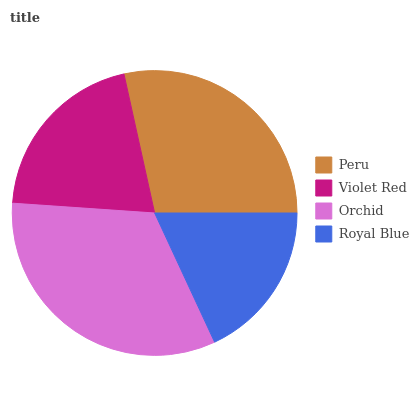Is Royal Blue the minimum?
Answer yes or no. Yes. Is Orchid the maximum?
Answer yes or no. Yes. Is Violet Red the minimum?
Answer yes or no. No. Is Violet Red the maximum?
Answer yes or no. No. Is Peru greater than Violet Red?
Answer yes or no. Yes. Is Violet Red less than Peru?
Answer yes or no. Yes. Is Violet Red greater than Peru?
Answer yes or no. No. Is Peru less than Violet Red?
Answer yes or no. No. Is Peru the high median?
Answer yes or no. Yes. Is Violet Red the low median?
Answer yes or no. Yes. Is Royal Blue the high median?
Answer yes or no. No. Is Royal Blue the low median?
Answer yes or no. No. 